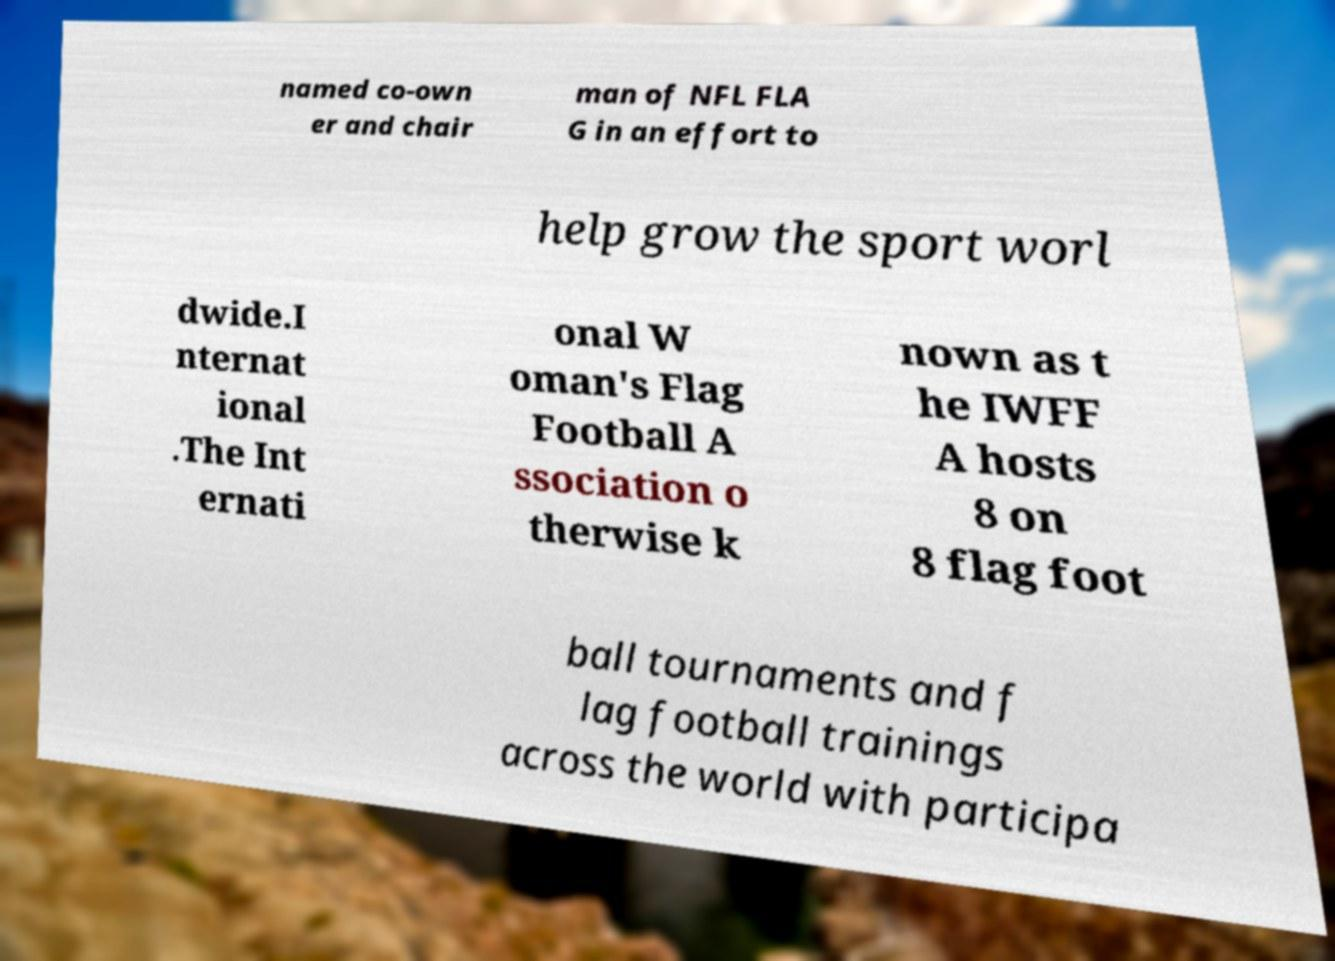Can you read and provide the text displayed in the image?This photo seems to have some interesting text. Can you extract and type it out for me? named co-own er and chair man of NFL FLA G in an effort to help grow the sport worl dwide.I nternat ional .The Int ernati onal W oman's Flag Football A ssociation o therwise k nown as t he IWFF A hosts 8 on 8 flag foot ball tournaments and f lag football trainings across the world with participa 